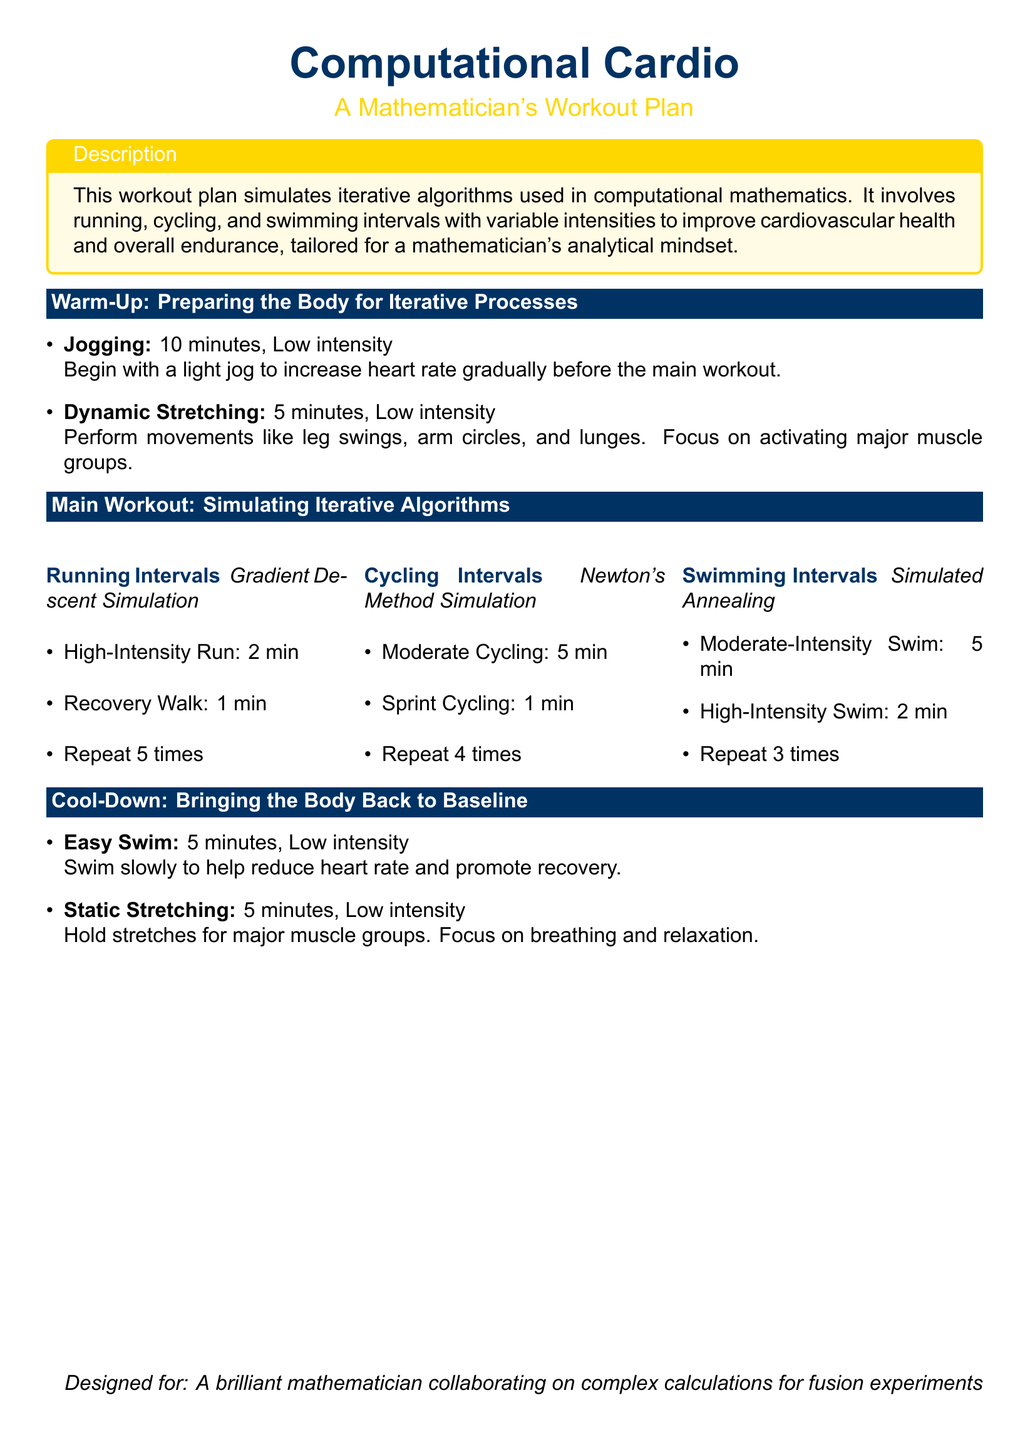what are the three main workout activities? The document lists running, cycling, and swimming as the three main workout activities.
Answer: running, cycling, swimming what is the high-intensity run duration in the running intervals? The high-intensity run in the running intervals is specified as 2 minutes.
Answer: 2 min how many times should the running intervals be repeated? The document states that the running intervals should be repeated 5 times.
Answer: 5 times what is the purpose of the easy swim in the cool-down section? The easy swim is designed to help reduce heart rate and promote recovery.
Answer: reduce heart rate which simulation represents the swimming intervals? The swimming intervals are represented by the term "Simulated Annealing."
Answer: Simulated Annealing how long is the warm-up phase? The warm-up phase consists of 15 minutes in total (10 min jogging + 5 min dynamic stretching).
Answer: 15 minutes what type of stretching is performed during the cool-down? The document describes static stretching as the type performed during the cool-down.
Answer: static stretching which interval simulation involves sprint cycling? The cycling intervals that involve sprint cycling are referred to as "Newton's Method Simulation."
Answer: Newton's Method Simulation what is the focus of the dynamic stretching? The dynamic stretching focuses on activating major muscle groups.
Answer: activating major muscle groups 